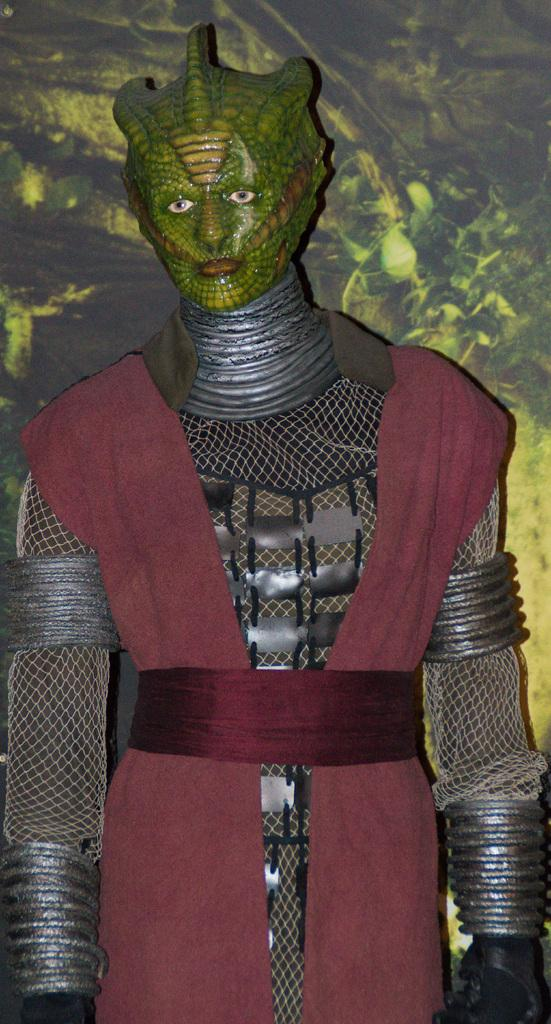Who or what is present in the image? There is a person in the image. What is the person wearing? The person is wearing a costume. What type of underwear is the moon wearing in the image? There is no moon or underwear present in the image. 